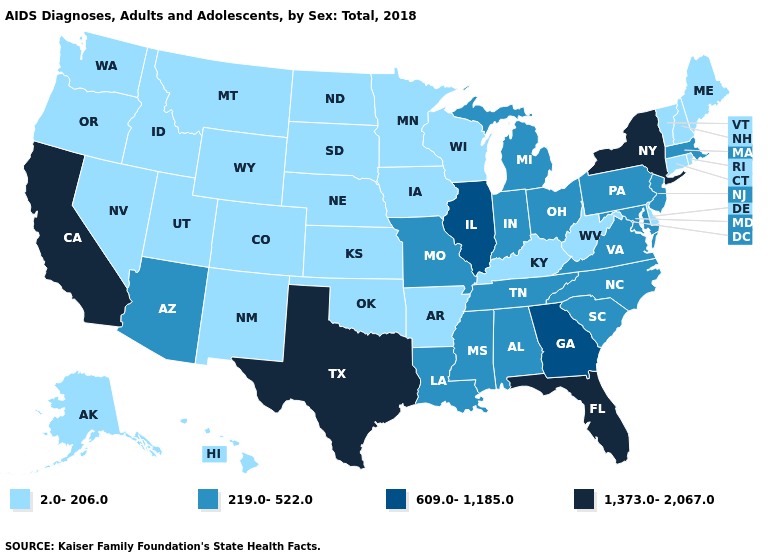Which states have the lowest value in the Northeast?
Short answer required. Connecticut, Maine, New Hampshire, Rhode Island, Vermont. Does Montana have the lowest value in the West?
Give a very brief answer. Yes. Does Massachusetts have the lowest value in the Northeast?
Quick response, please. No. Among the states that border Wisconsin , does Michigan have the lowest value?
Short answer required. No. What is the value of New Mexico?
Concise answer only. 2.0-206.0. How many symbols are there in the legend?
Short answer required. 4. Among the states that border Nebraska , does Colorado have the lowest value?
Keep it brief. Yes. What is the value of Montana?
Concise answer only. 2.0-206.0. What is the lowest value in states that border Texas?
Be succinct. 2.0-206.0. What is the value of Minnesota?
Concise answer only. 2.0-206.0. What is the value of California?
Quick response, please. 1,373.0-2,067.0. What is the lowest value in the West?
Quick response, please. 2.0-206.0. Name the states that have a value in the range 219.0-522.0?
Answer briefly. Alabama, Arizona, Indiana, Louisiana, Maryland, Massachusetts, Michigan, Mississippi, Missouri, New Jersey, North Carolina, Ohio, Pennsylvania, South Carolina, Tennessee, Virginia. What is the highest value in the Northeast ?
Quick response, please. 1,373.0-2,067.0. How many symbols are there in the legend?
Give a very brief answer. 4. 